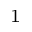Convert formula to latex. <formula><loc_0><loc_0><loc_500><loc_500>_ { 1 }</formula> 